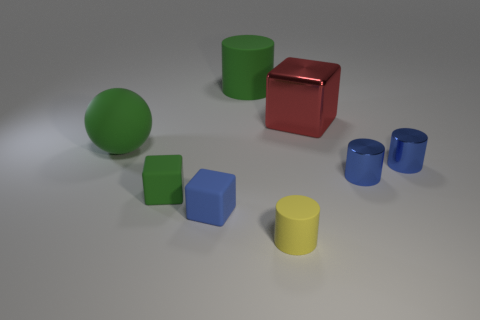There is a big green object on the right side of the large rubber ball; is there a cube that is to the left of it? yes 